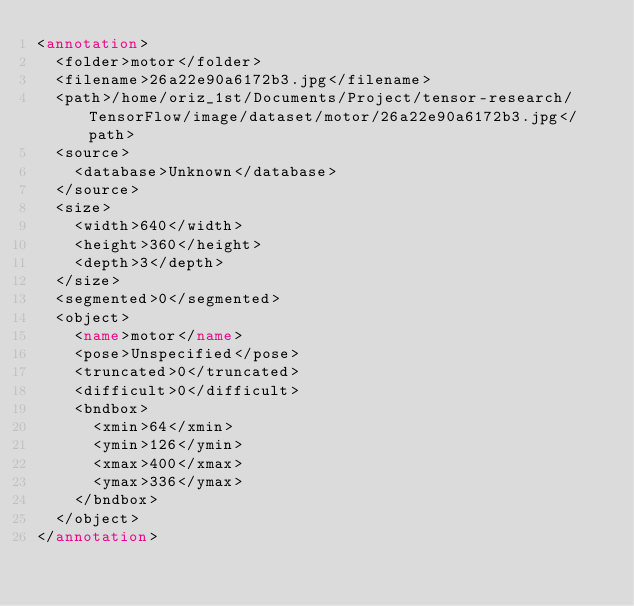<code> <loc_0><loc_0><loc_500><loc_500><_XML_><annotation>
	<folder>motor</folder>
	<filename>26a22e90a6172b3.jpg</filename>
	<path>/home/oriz_1st/Documents/Project/tensor-research/TensorFlow/image/dataset/motor/26a22e90a6172b3.jpg</path>
	<source>
		<database>Unknown</database>
	</source>
	<size>
		<width>640</width>
		<height>360</height>
		<depth>3</depth>
	</size>
	<segmented>0</segmented>
	<object>
		<name>motor</name>
		<pose>Unspecified</pose>
		<truncated>0</truncated>
		<difficult>0</difficult>
		<bndbox>
			<xmin>64</xmin>
			<ymin>126</ymin>
			<xmax>400</xmax>
			<ymax>336</ymax>
		</bndbox>
	</object>
</annotation>
</code> 